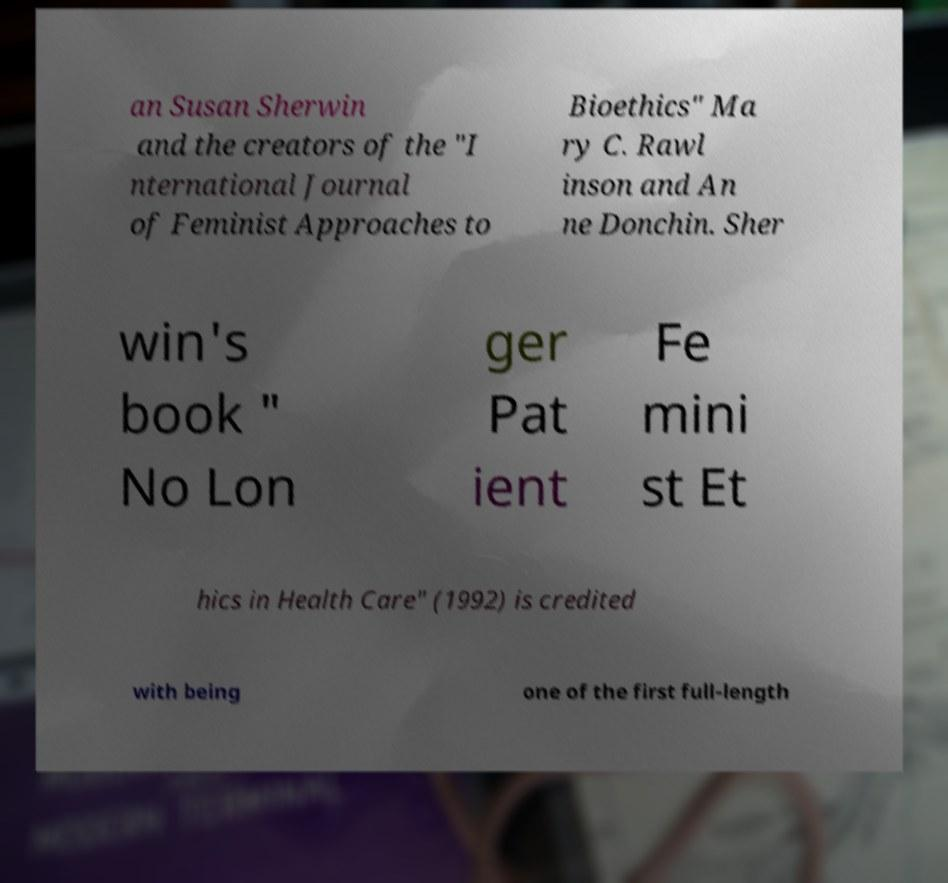Could you assist in decoding the text presented in this image and type it out clearly? an Susan Sherwin and the creators of the "I nternational Journal of Feminist Approaches to Bioethics" Ma ry C. Rawl inson and An ne Donchin. Sher win's book " No Lon ger Pat ient Fe mini st Et hics in Health Care" (1992) is credited with being one of the first full-length 